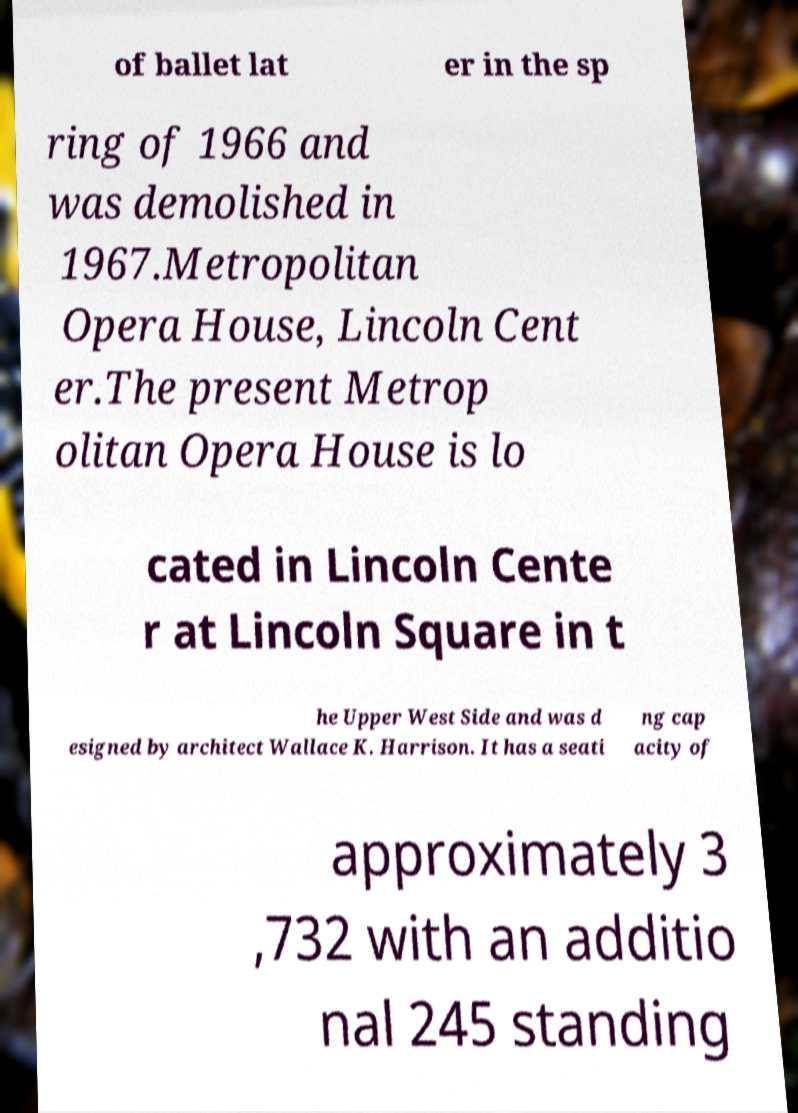Could you extract and type out the text from this image? of ballet lat er in the sp ring of 1966 and was demolished in 1967.Metropolitan Opera House, Lincoln Cent er.The present Metrop olitan Opera House is lo cated in Lincoln Cente r at Lincoln Square in t he Upper West Side and was d esigned by architect Wallace K. Harrison. It has a seati ng cap acity of approximately 3 ,732 with an additio nal 245 standing 